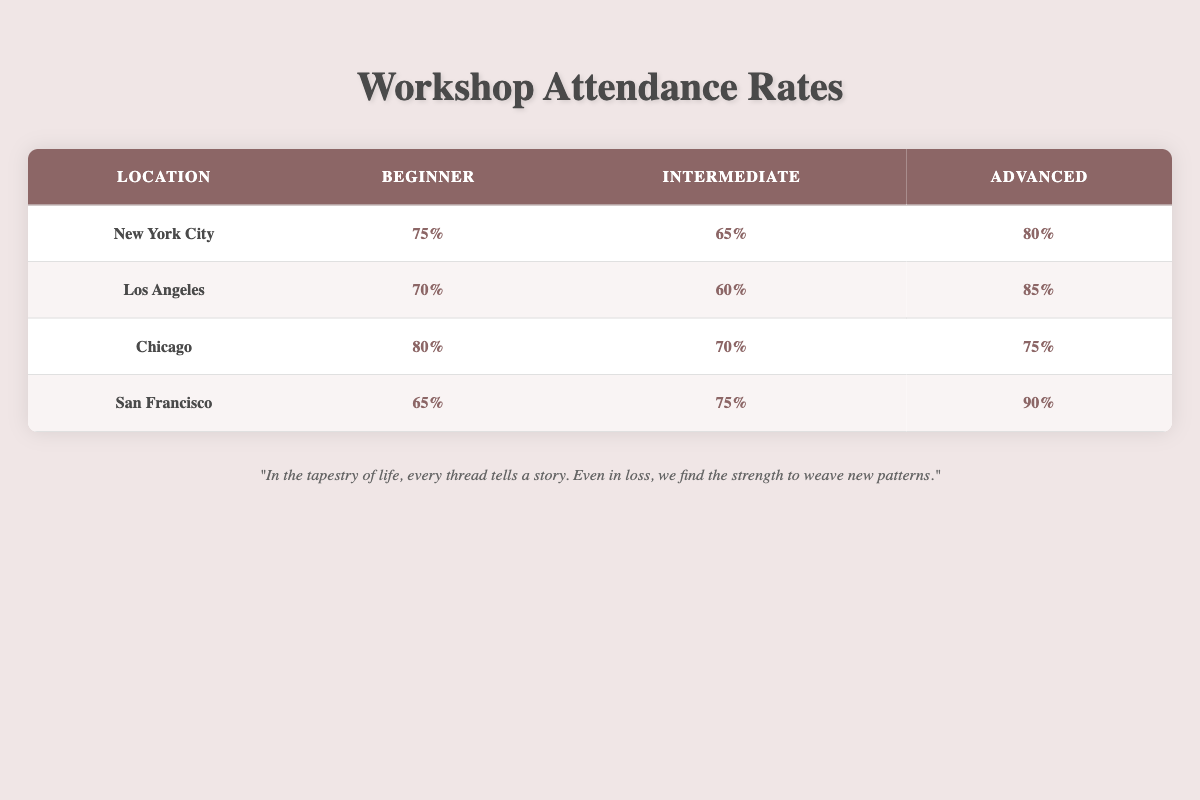What is the attendance rate for Advanced participants in San Francisco? The table shows that under the San Francisco location, the attendance rate for Advanced participants is listed directly as 90%.
Answer: 90% Which location has the highest attendance rate for Beginner participants? By comparing the Beginner rates across the locations, New York City has a rate of 75%, Los Angeles has 70%, Chicago has 80%, and San Francisco has 65%. The highest among these is 80% in Chicago.
Answer: Chicago What is the average attendance rate for Intermediate participants across all locations? The Intermediate rates from each location are 65% (New York City), 60% (Los Angeles), 70% (Chicago), and 75% (San Francisco). Adding these rates gives 265%, and dividing by 4 (the number of locations) provides an average of 66.25%.
Answer: 66.25% Is the attendance rate for Beginner participants in Los Angeles higher than that in San Francisco? The attendance rate for Beginner participants in Los Angeles is 70%, while in San Francisco it is 65%. Since 70% is greater than 65%, the statement is true.
Answer: Yes Which experience level has the lowest attendance rate overall? Looking at each experience level across the locations: for Beginners, it's 65% (San Francisco); for Intermediate, it's 60% (Los Angeles); and for Advanced, it's 75% (Chicago). The lowest attendance rate belongs to Intermediate participants at 60%.
Answer: Intermediate 